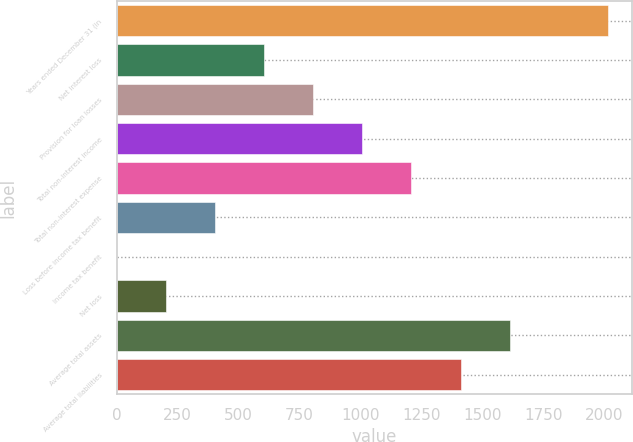Convert chart. <chart><loc_0><loc_0><loc_500><loc_500><bar_chart><fcel>Years ended December 31 (in<fcel>Net interest loss<fcel>Provision for loan losses<fcel>Total non-interest income<fcel>Total non-interest expense<fcel>Loss before income tax benefit<fcel>Income tax benefit<fcel>Net loss<fcel>Average total assets<fcel>Average total liabilities<nl><fcel>2014<fcel>604.41<fcel>805.78<fcel>1007.15<fcel>1208.52<fcel>403.04<fcel>0.3<fcel>201.67<fcel>1611.26<fcel>1409.89<nl></chart> 